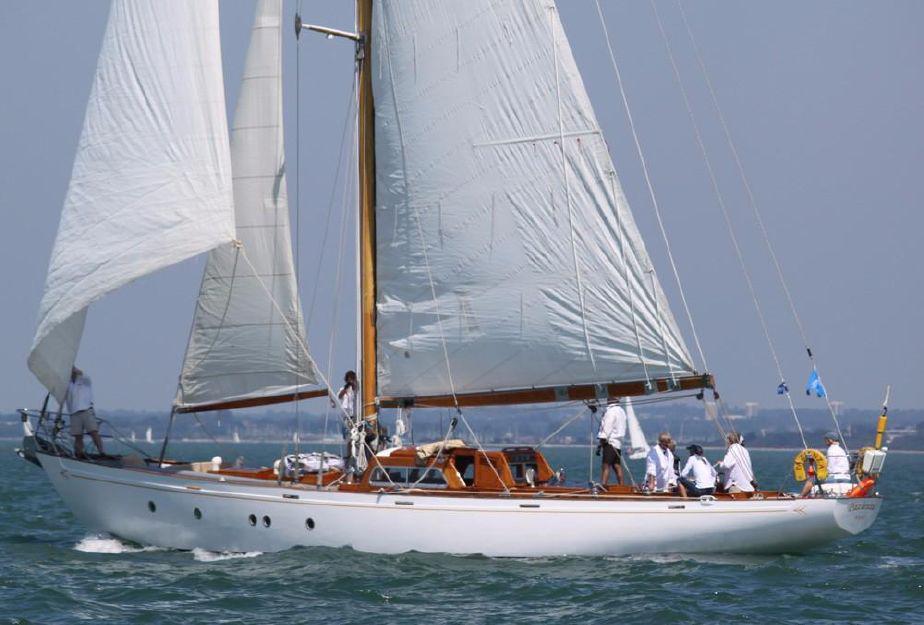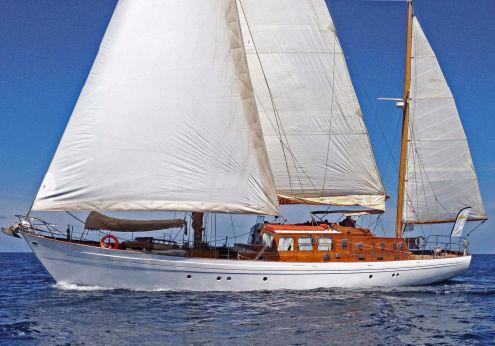The first image is the image on the left, the second image is the image on the right. Considering the images on both sides, is "A sailboat with three white sails is tilted sideways towards the water." valid? Answer yes or no. No. 